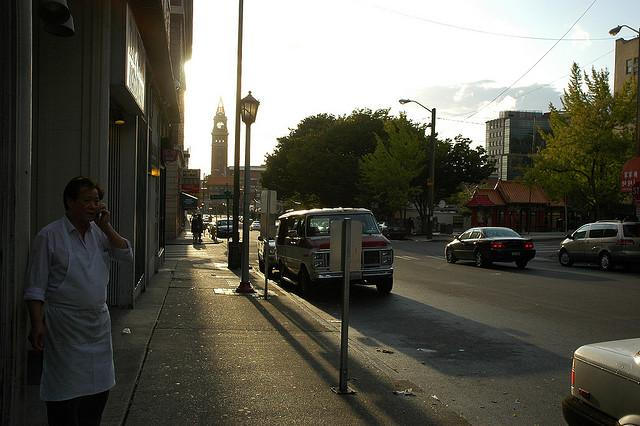What is the man in white apron holding to his ear? Please explain your reasoning. cellphone. The man in the white apron is holding an electronic device, not a banana, ice pack, or bean bag, to his ear. 